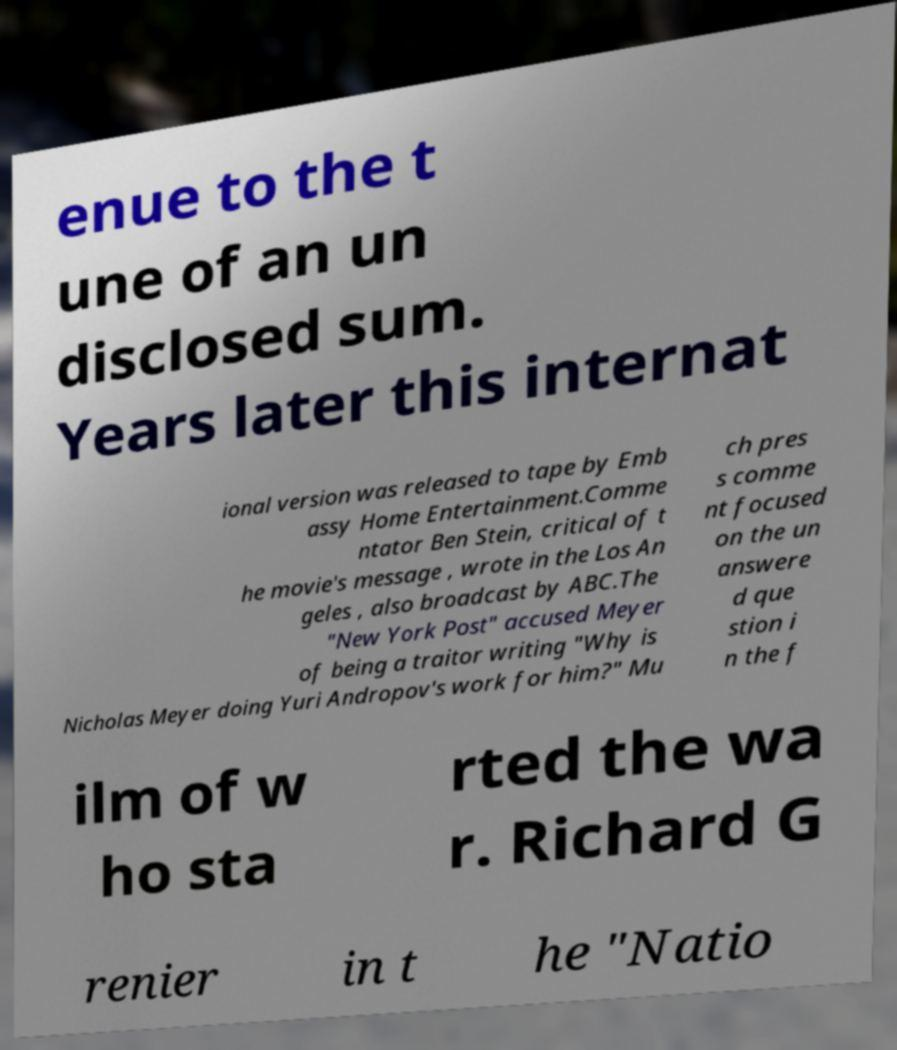What messages or text are displayed in this image? I need them in a readable, typed format. enue to the t une of an un disclosed sum. Years later this internat ional version was released to tape by Emb assy Home Entertainment.Comme ntator Ben Stein, critical of t he movie's message , wrote in the Los An geles , also broadcast by ABC.The "New York Post" accused Meyer of being a traitor writing "Why is Nicholas Meyer doing Yuri Andropov's work for him?" Mu ch pres s comme nt focused on the un answere d que stion i n the f ilm of w ho sta rted the wa r. Richard G renier in t he "Natio 